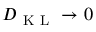Convert formula to latex. <formula><loc_0><loc_0><loc_500><loc_500>D _ { K L } \rightarrow 0</formula> 